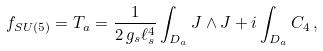<formula> <loc_0><loc_0><loc_500><loc_500>f _ { S U ( 5 ) } = T _ { a } = \frac { 1 } { 2 \, g _ { s } \ell _ { s } ^ { 4 } } \int _ { D _ { a } } J \wedge J + i \int _ { D _ { a } } C _ { 4 } \, ,</formula> 